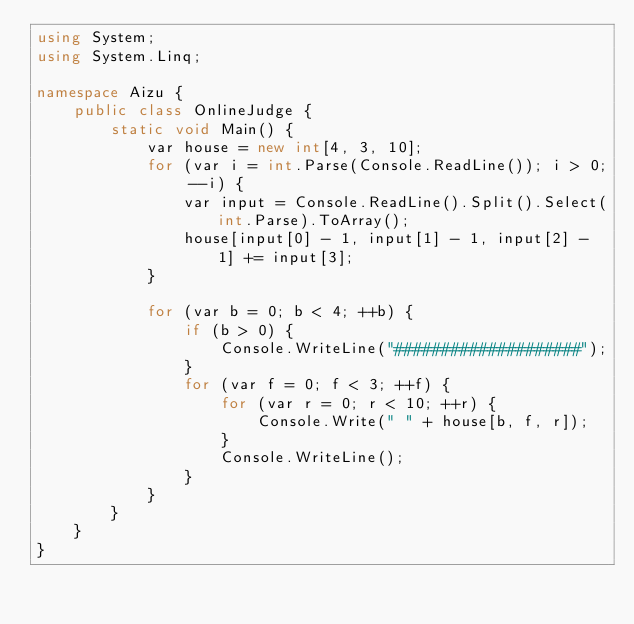Convert code to text. <code><loc_0><loc_0><loc_500><loc_500><_C#_>using System;
using System.Linq;

namespace Aizu {
    public class OnlineJudge {
        static void Main() {
            var house = new int[4, 3, 10];
            for (var i = int.Parse(Console.ReadLine()); i > 0; --i) {
                var input = Console.ReadLine().Split().Select(int.Parse).ToArray();
                house[input[0] - 1, input[1] - 1, input[2] - 1] += input[3];
            }

            for (var b = 0; b < 4; ++b) {
                if (b > 0) {
                    Console.WriteLine("####################");
                }
                for (var f = 0; f < 3; ++f) {
                    for (var r = 0; r < 10; ++r) {
                        Console.Write(" " + house[b, f, r]);
                    }
                    Console.WriteLine();
                }
            }
        }
    }
}

</code> 